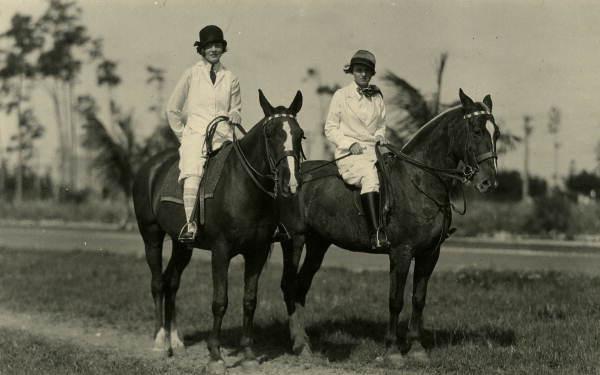How many horses are seen in the image?
Give a very brief answer. 2. How many animals can be seen?
Give a very brief answer. 2. How many  horses are standing next to each other?
Give a very brief answer. 2. How many men are wearing hats?
Give a very brief answer. 2. How many people can be seen?
Give a very brief answer. 2. How many people are in the photo?
Give a very brief answer. 2. How many horses can be seen?
Give a very brief answer. 2. How many donuts have holes?
Give a very brief answer. 0. 